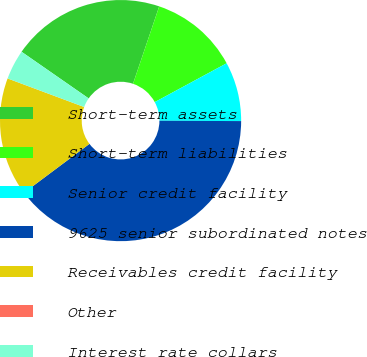<chart> <loc_0><loc_0><loc_500><loc_500><pie_chart><fcel>Short-term assets<fcel>Short-term liabilities<fcel>Senior credit facility<fcel>9625 senior subordinated notes<fcel>Receivables credit facility<fcel>Other<fcel>Interest rate collars<nl><fcel>20.52%<fcel>11.92%<fcel>7.95%<fcel>39.71%<fcel>15.89%<fcel>0.01%<fcel>3.98%<nl></chart> 